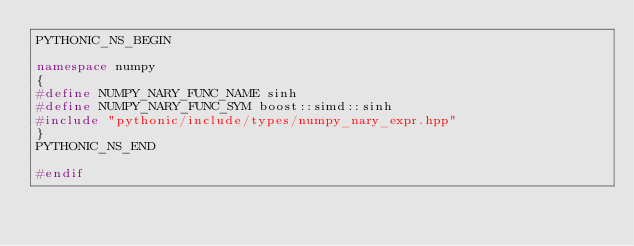<code> <loc_0><loc_0><loc_500><loc_500><_C++_>PYTHONIC_NS_BEGIN

namespace numpy
{
#define NUMPY_NARY_FUNC_NAME sinh
#define NUMPY_NARY_FUNC_SYM boost::simd::sinh
#include "pythonic/include/types/numpy_nary_expr.hpp"
}
PYTHONIC_NS_END

#endif
</code> 